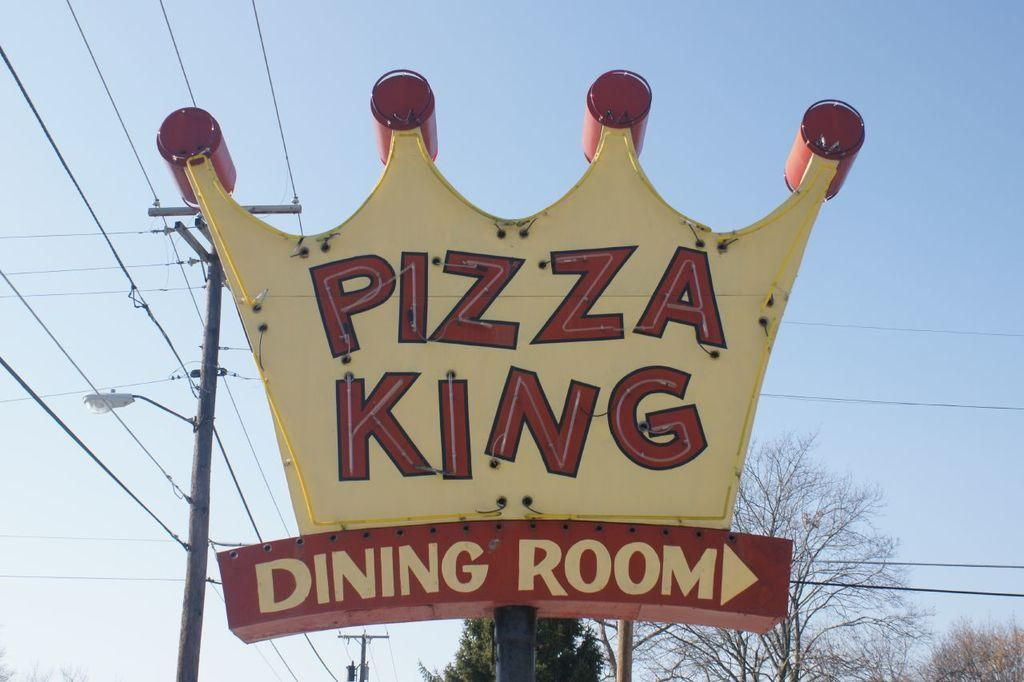What is the main object in the image? There is a name board in the image. What can be seen behind the name board? There are trees behind the name board. What else is present in the image besides the name board and trees? There are electric poles with cables in the image. What is visible in the background behind the trees? The sky is visible behind the trees. What is the name board's relation to the father in the image? There is no father or relation mentioned in the image; it only features a name board, trees, and electric poles with cables. 